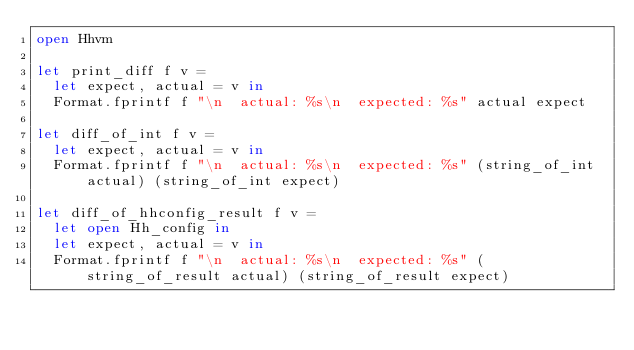Convert code to text. <code><loc_0><loc_0><loc_500><loc_500><_OCaml_>open Hhvm

let print_diff f v =
  let expect, actual = v in
  Format.fprintf f "\n  actual: %s\n  expected: %s" actual expect

let diff_of_int f v =
  let expect, actual = v in
  Format.fprintf f "\n  actual: %s\n  expected: %s" (string_of_int actual) (string_of_int expect)

let diff_of_hhconfig_result f v =
  let open Hh_config in
  let expect, actual = v in
  Format.fprintf f "\n  actual: %s\n  expected: %s" (string_of_result actual) (string_of_result expect)
</code> 